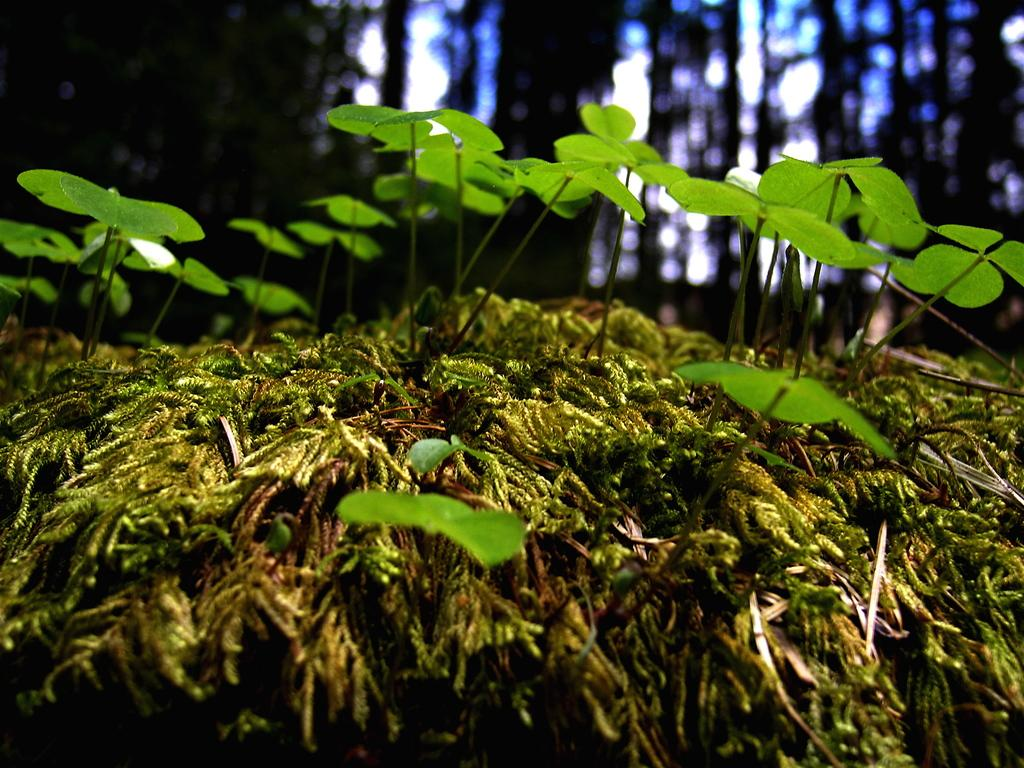What type of vegetation can be seen in the image? There is grass in the image. What else can be seen in the image besides grass? There are leaves in the image. What type of fruit is the secretary holding in the image? There is no person, let alone a secretary, present in the image. Additionally, there is no fruit visible. 